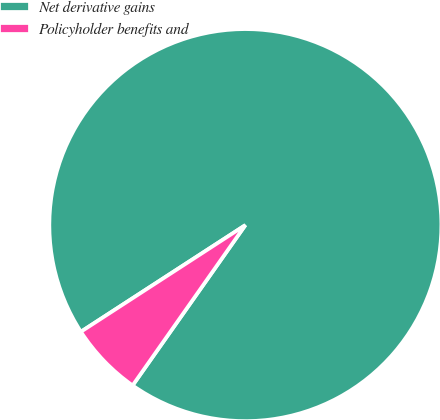<chart> <loc_0><loc_0><loc_500><loc_500><pie_chart><fcel>Net derivative gains<fcel>Policyholder benefits and<nl><fcel>93.91%<fcel>6.09%<nl></chart> 